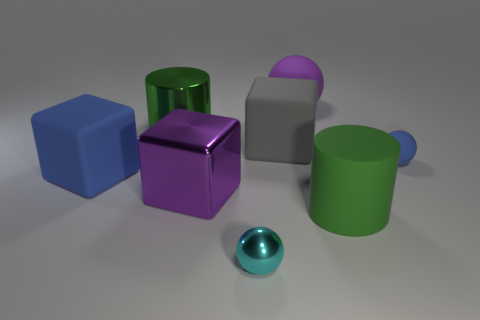Could you describe the lighting and atmosphere of the scene? The lighting in the scene is soft and diffused, casting gentle shadows and highlights on the objects. This creates a calm and serene atmosphere, with an emphasis on the aesthetic qualities of the shapes and materials present.  How are the objects arranged in relation to one another? The objects appear to be deliberately arranged with varying distances between them, creating a somewhat scattered yet cohesive composition that draws the eye across the image. 